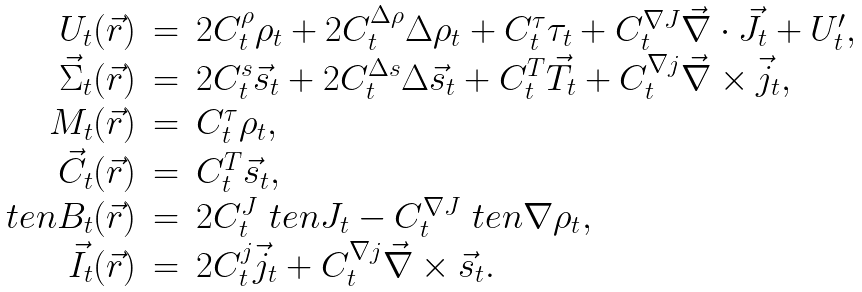Convert formula to latex. <formula><loc_0><loc_0><loc_500><loc_500>\begin{array} { r c l } U _ { t } ( \vec { r } ) & = & 2 C _ { t } ^ { \rho } \rho _ { t } + 2 C _ { t } ^ { \Delta \rho } \Delta \rho _ { t } + C _ { t } ^ { \tau } \tau _ { t } + C _ { t } ^ { \nabla J } \vec { \nabla } \cdot \vec { J } _ { t } + U _ { t } ^ { \prime } , \\ \vec { \Sigma } _ { t } ( \vec { r } ) & = & 2 C _ { t } ^ { s } \vec { s } _ { t } + 2 C _ { t } ^ { \Delta s } \Delta \vec { s } _ { t } + C _ { t } ^ { T } \vec { T } _ { t } + C _ { t } ^ { \nabla j } \vec { \nabla } \times \vec { j } _ { t } , \\ M _ { t } ( \vec { r } ) & = & C _ { t } ^ { \tau } \rho _ { t } , \\ \vec { C } _ { t } ( \vec { r } ) & = & C _ { t } ^ { T } \vec { s } _ { t } , \\ \ t e n { B } _ { t } ( \vec { r } ) & = & 2 C _ { t } ^ { J } \ t e n { J } _ { t } - C _ { t } ^ { \nabla J } \ t e n { \nabla } \rho _ { t } , \\ \vec { I } _ { t } ( \vec { r } ) & = & 2 C _ { t } ^ { j } \vec { j } _ { t } + C _ { t } ^ { \nabla j } \vec { \nabla } \times \vec { s } _ { t } . \end{array}</formula> 